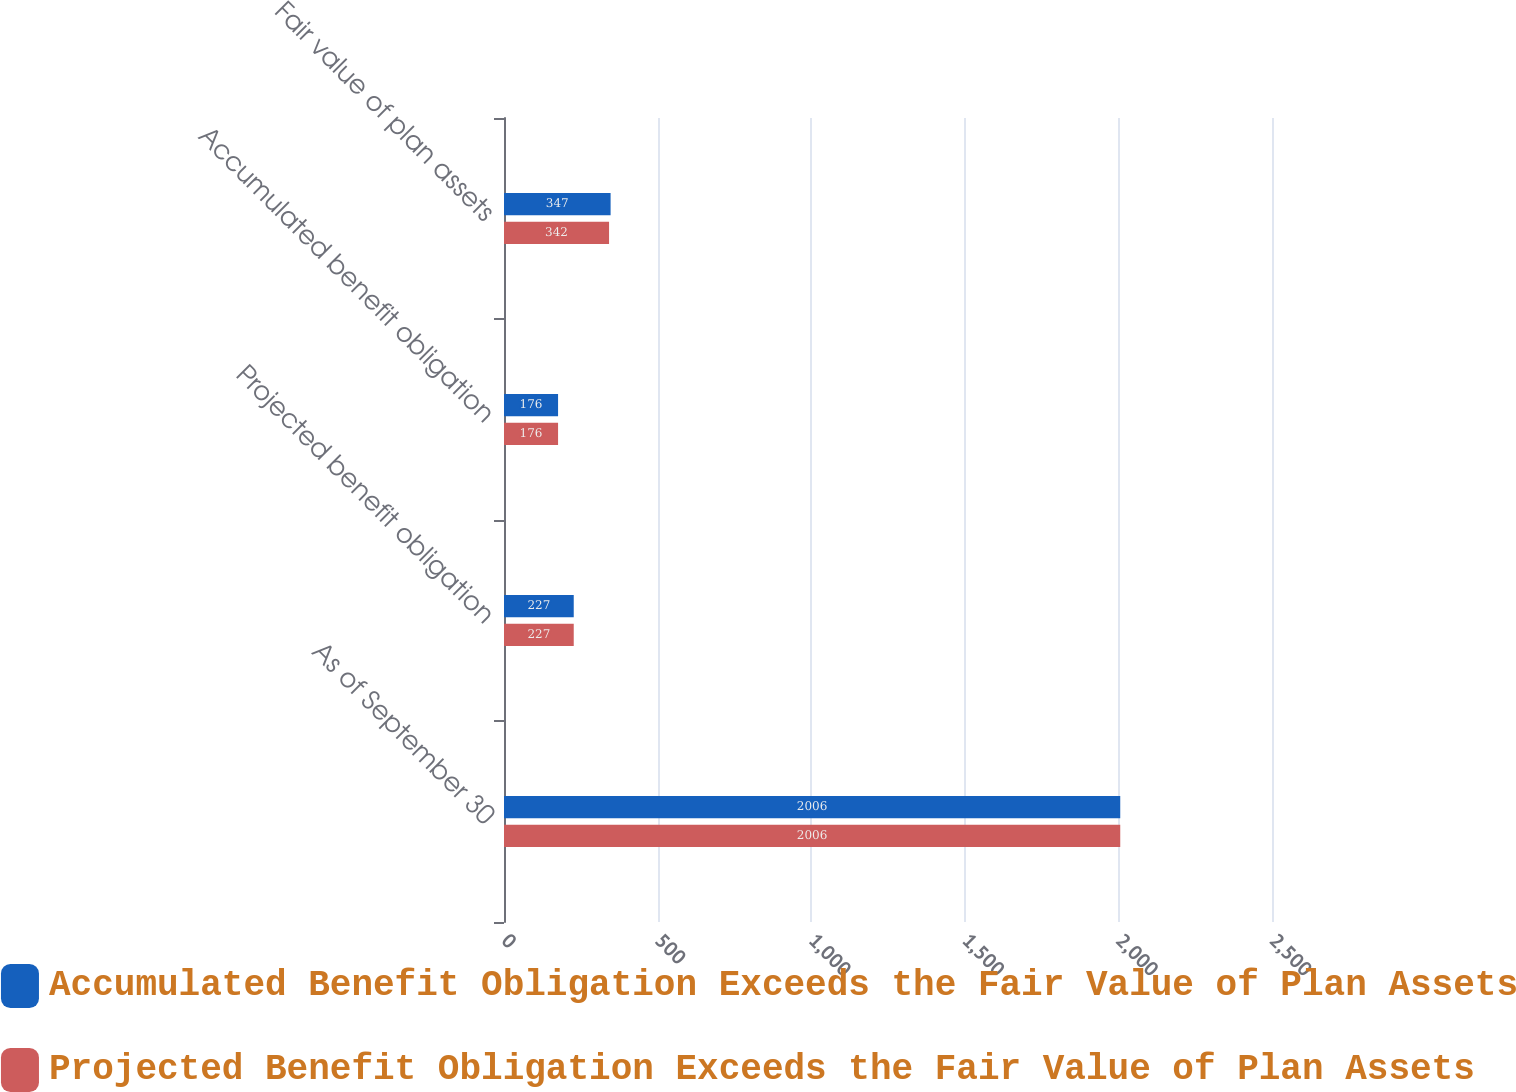Convert chart. <chart><loc_0><loc_0><loc_500><loc_500><stacked_bar_chart><ecel><fcel>As of September 30<fcel>Projected benefit obligation<fcel>Accumulated benefit obligation<fcel>Fair value of plan assets<nl><fcel>Accumulated Benefit Obligation Exceeds the Fair Value of Plan Assets<fcel>2006<fcel>227<fcel>176<fcel>347<nl><fcel>Projected Benefit Obligation Exceeds the Fair Value of Plan Assets<fcel>2006<fcel>227<fcel>176<fcel>342<nl></chart> 